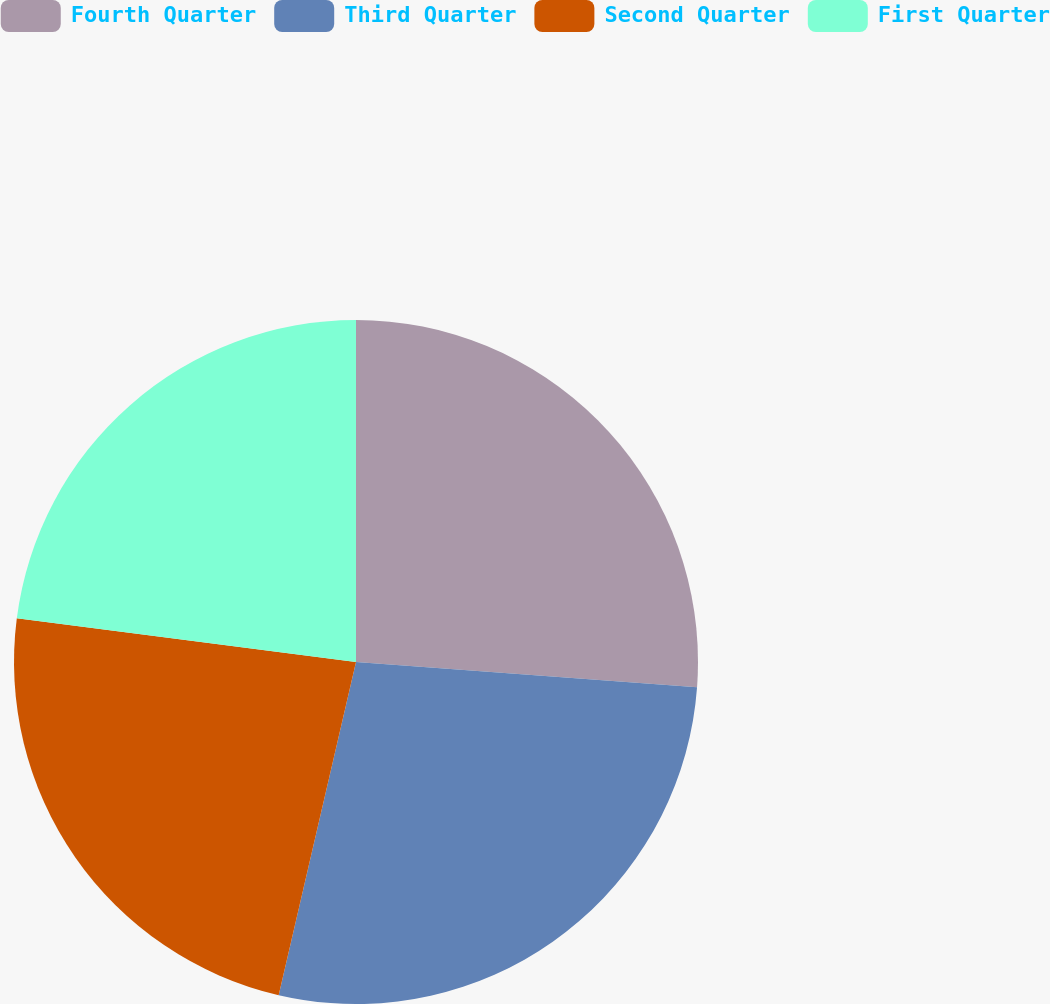<chart> <loc_0><loc_0><loc_500><loc_500><pie_chart><fcel>Fourth Quarter<fcel>Third Quarter<fcel>Second Quarter<fcel>First Quarter<nl><fcel>26.18%<fcel>27.45%<fcel>23.41%<fcel>22.96%<nl></chart> 